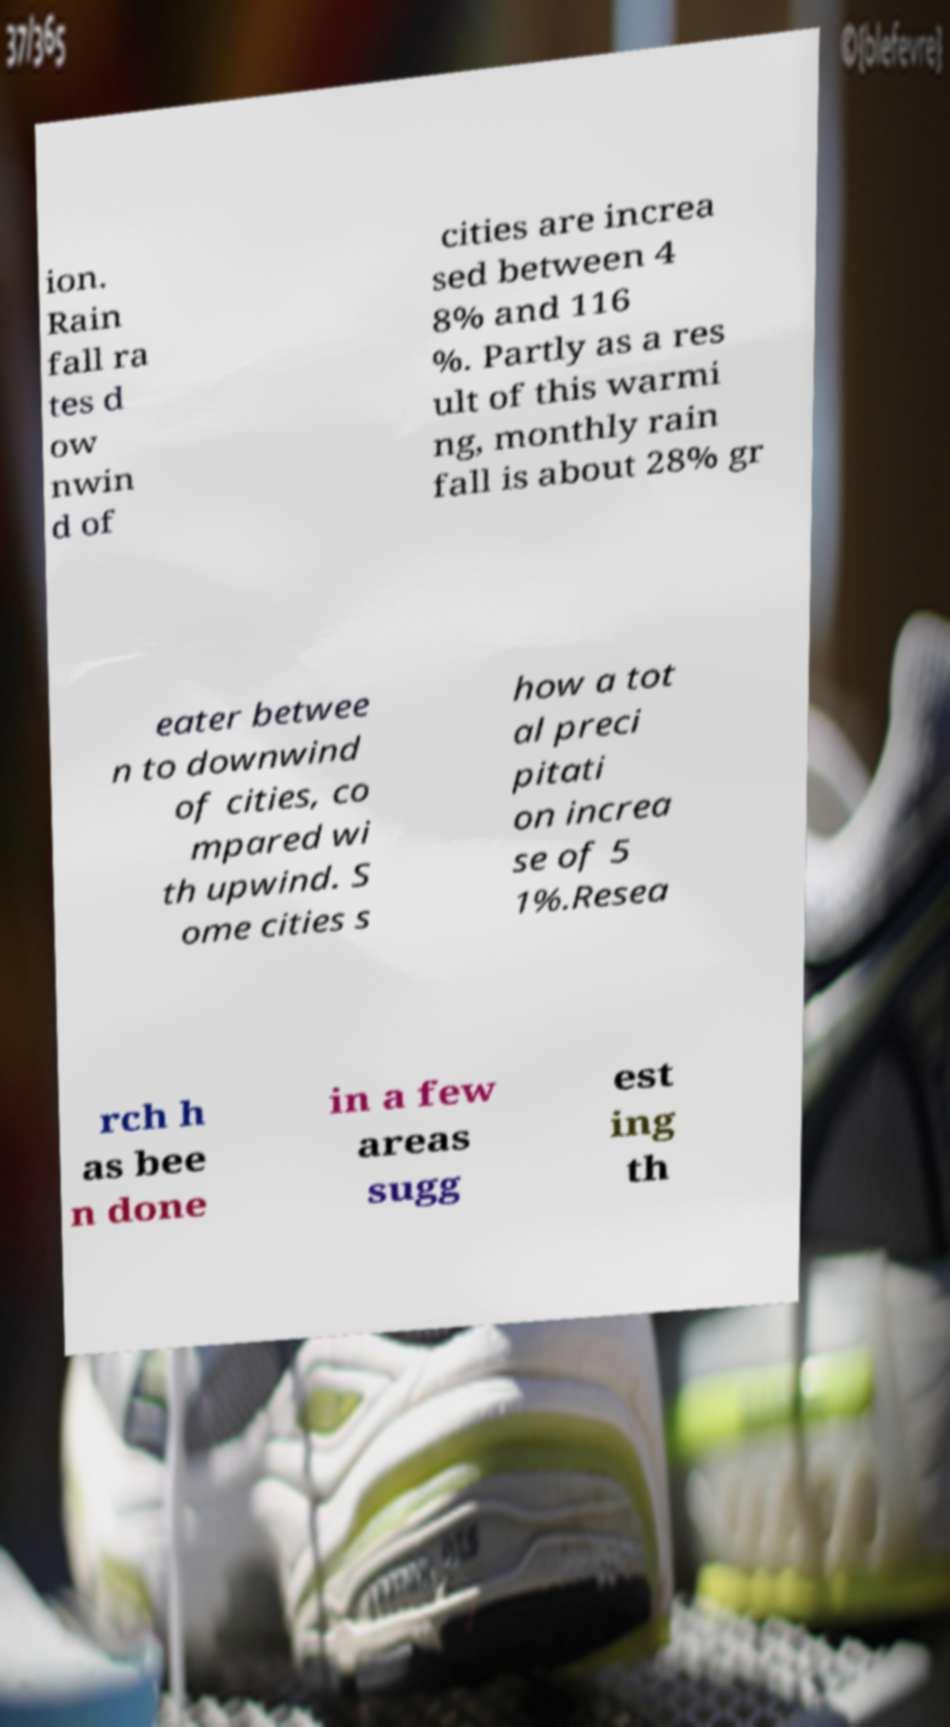Please identify and transcribe the text found in this image. ion. Rain fall ra tes d ow nwin d of cities are increa sed between 4 8% and 116 %. Partly as a res ult of this warmi ng, monthly rain fall is about 28% gr eater betwee n to downwind of cities, co mpared wi th upwind. S ome cities s how a tot al preci pitati on increa se of 5 1%.Resea rch h as bee n done in a few areas sugg est ing th 